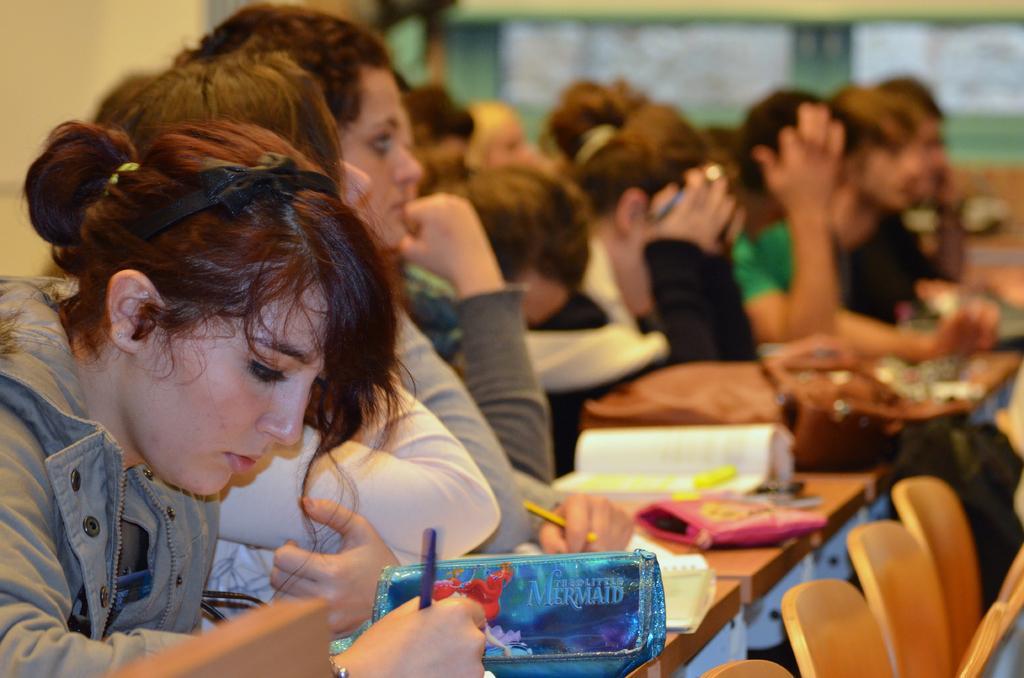Describe this image in one or two sentences. In this image on the right side, I can see the chairs. I can see some objects on the table. I can see some people. In the background, I can see the wall. 